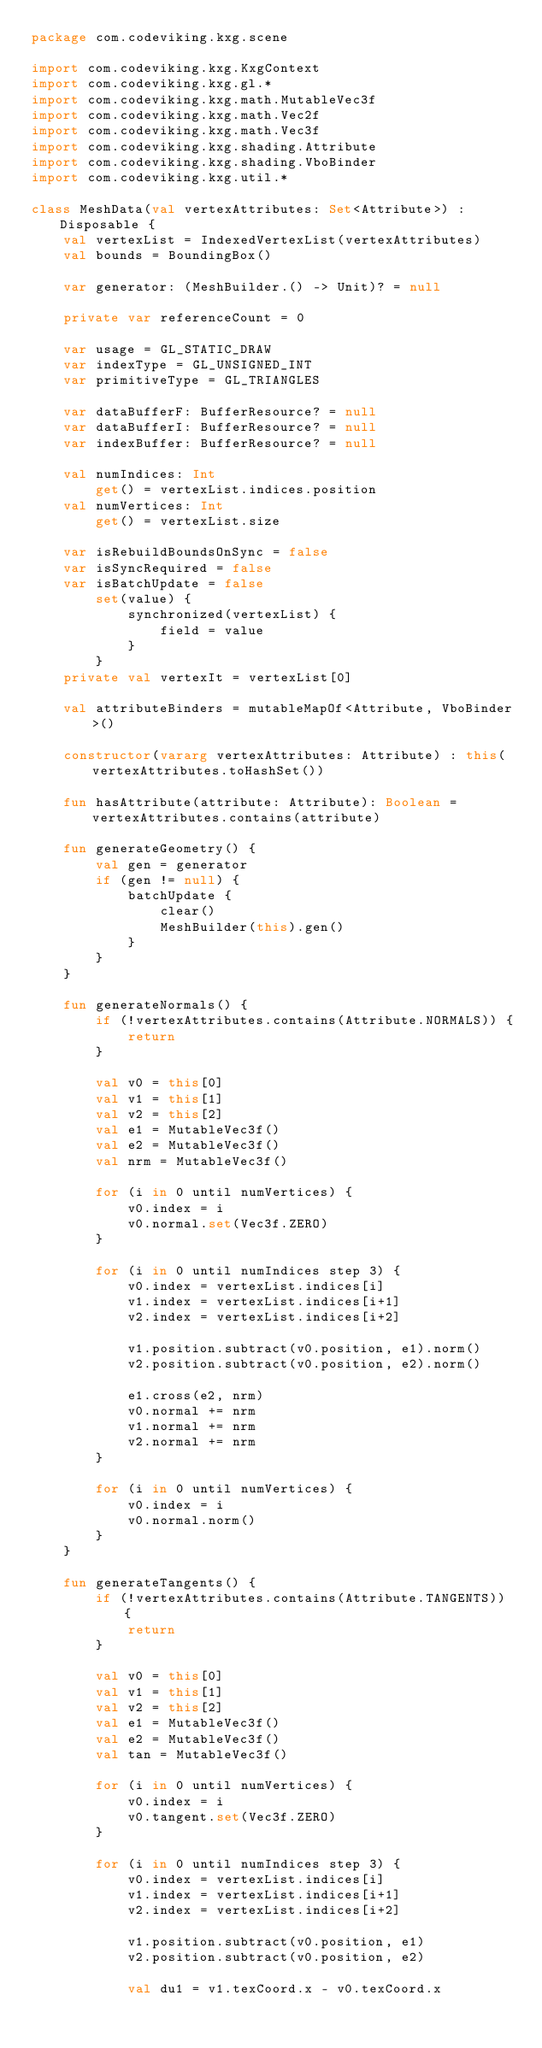<code> <loc_0><loc_0><loc_500><loc_500><_Kotlin_>package com.codeviking.kxg.scene

import com.codeviking.kxg.KxgContext
import com.codeviking.kxg.gl.*
import com.codeviking.kxg.math.MutableVec3f
import com.codeviking.kxg.math.Vec2f
import com.codeviking.kxg.math.Vec3f
import com.codeviking.kxg.shading.Attribute
import com.codeviking.kxg.shading.VboBinder
import com.codeviking.kxg.util.*

class MeshData(val vertexAttributes: Set<Attribute>) : Disposable {
    val vertexList = IndexedVertexList(vertexAttributes)
    val bounds = BoundingBox()

    var generator: (MeshBuilder.() -> Unit)? = null

    private var referenceCount = 0

    var usage = GL_STATIC_DRAW
    var indexType = GL_UNSIGNED_INT
    var primitiveType = GL_TRIANGLES

    var dataBufferF: BufferResource? = null
    var dataBufferI: BufferResource? = null
    var indexBuffer: BufferResource? = null

    val numIndices: Int
        get() = vertexList.indices.position
    val numVertices: Int
        get() = vertexList.size

    var isRebuildBoundsOnSync = false
    var isSyncRequired = false
    var isBatchUpdate = false
        set(value) {
            synchronized(vertexList) {
                field = value
            }
        }
    private val vertexIt = vertexList[0]

    val attributeBinders = mutableMapOf<Attribute, VboBinder>()

    constructor(vararg vertexAttributes: Attribute) : this(vertexAttributes.toHashSet())

    fun hasAttribute(attribute: Attribute): Boolean = vertexAttributes.contains(attribute)

    fun generateGeometry() {
        val gen = generator
        if (gen != null) {
            batchUpdate {
                clear()
                MeshBuilder(this).gen()
            }
        }
    }

    fun generateNormals() {
        if (!vertexAttributes.contains(Attribute.NORMALS)) {
            return
        }

        val v0 = this[0]
        val v1 = this[1]
        val v2 = this[2]
        val e1 = MutableVec3f()
        val e2 = MutableVec3f()
        val nrm = MutableVec3f()

        for (i in 0 until numVertices) {
            v0.index = i
            v0.normal.set(Vec3f.ZERO)
        }

        for (i in 0 until numIndices step 3) {
            v0.index = vertexList.indices[i]
            v1.index = vertexList.indices[i+1]
            v2.index = vertexList.indices[i+2]

            v1.position.subtract(v0.position, e1).norm()
            v2.position.subtract(v0.position, e2).norm()

            e1.cross(e2, nrm)
            v0.normal += nrm
            v1.normal += nrm
            v2.normal += nrm
        }

        for (i in 0 until numVertices) {
            v0.index = i
            v0.normal.norm()
        }
    }

    fun generateTangents() {
        if (!vertexAttributes.contains(Attribute.TANGENTS)) {
            return
        }

        val v0 = this[0]
        val v1 = this[1]
        val v2 = this[2]
        val e1 = MutableVec3f()
        val e2 = MutableVec3f()
        val tan = MutableVec3f()

        for (i in 0 until numVertices) {
            v0.index = i
            v0.tangent.set(Vec3f.ZERO)
        }

        for (i in 0 until numIndices step 3) {
            v0.index = vertexList.indices[i]
            v1.index = vertexList.indices[i+1]
            v2.index = vertexList.indices[i+2]

            v1.position.subtract(v0.position, e1)
            v2.position.subtract(v0.position, e2)

            val du1 = v1.texCoord.x - v0.texCoord.x</code> 